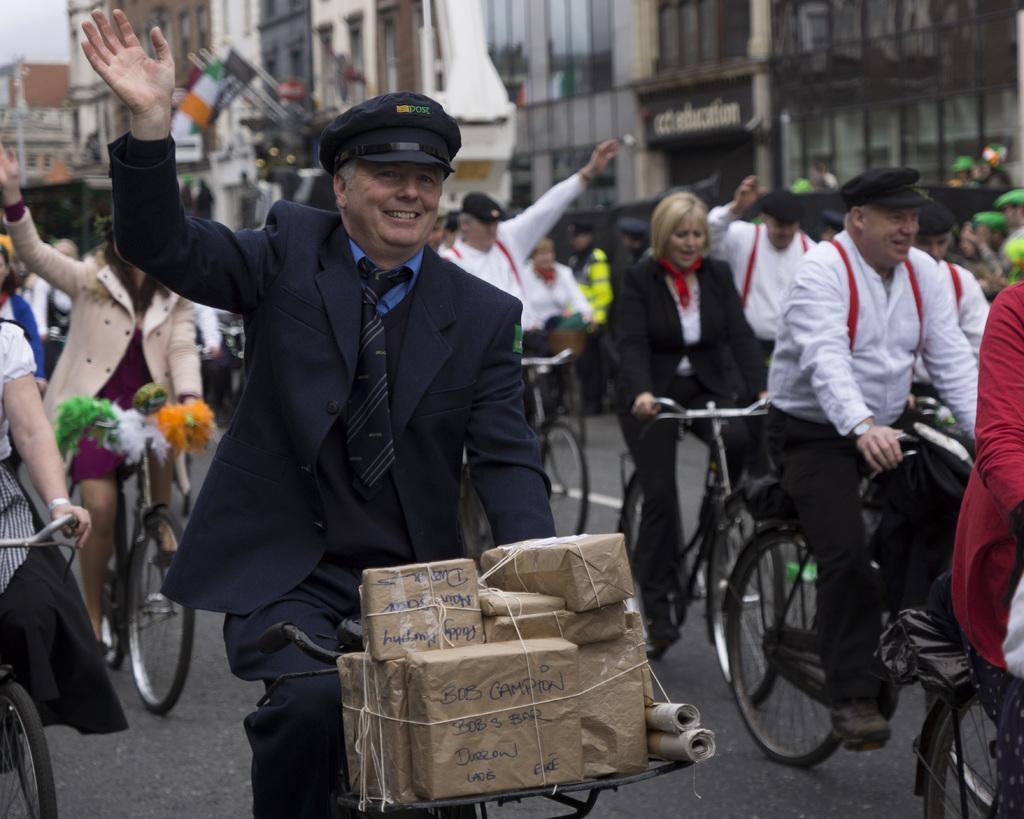Can you describe this image briefly? In this picture many people are riding the bicycles and waving their hands ,in the background we observe many buildings. 